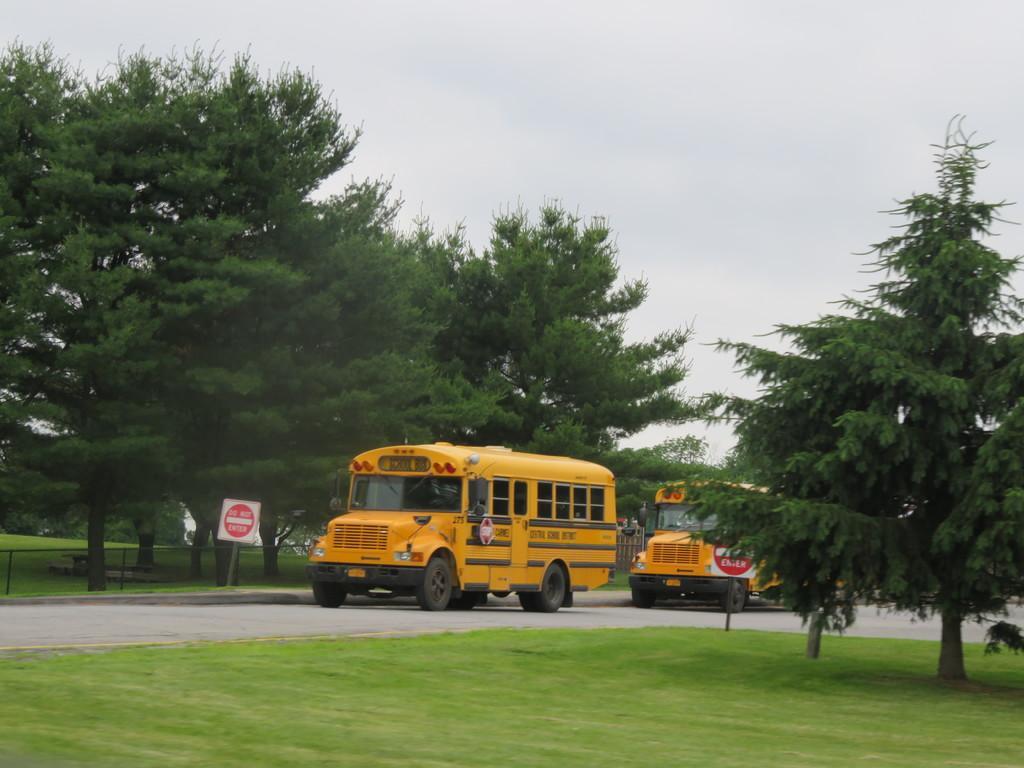Describe this image in one or two sentences. In the center of the picture there are buses, sign board, trees, railing, road and grass. In the foreground there is grass. Sky is cloudy. 